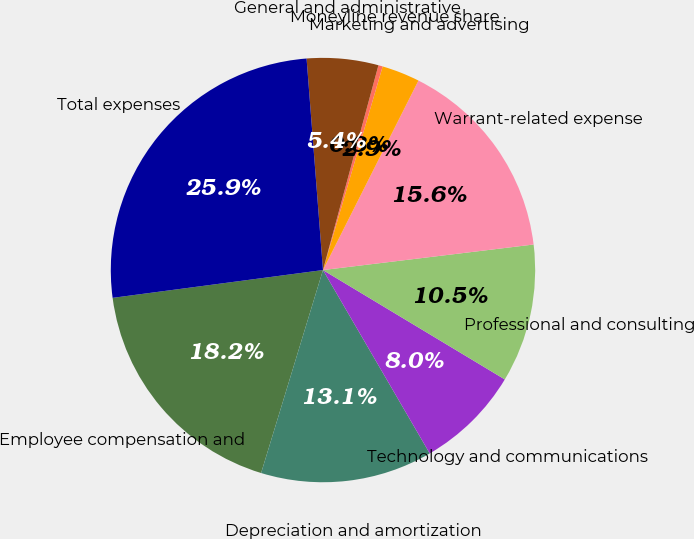Convert chart. <chart><loc_0><loc_0><loc_500><loc_500><pie_chart><fcel>Employee compensation and<fcel>Depreciation and amortization<fcel>Technology and communications<fcel>Professional and consulting<fcel>Warrant-related expense<fcel>Marketing and advertising<fcel>Moneyline revenue share<fcel>General and administrative<fcel>Total expenses<nl><fcel>18.2%<fcel>13.1%<fcel>7.99%<fcel>10.54%<fcel>15.65%<fcel>2.89%<fcel>0.33%<fcel>5.44%<fcel>25.86%<nl></chart> 